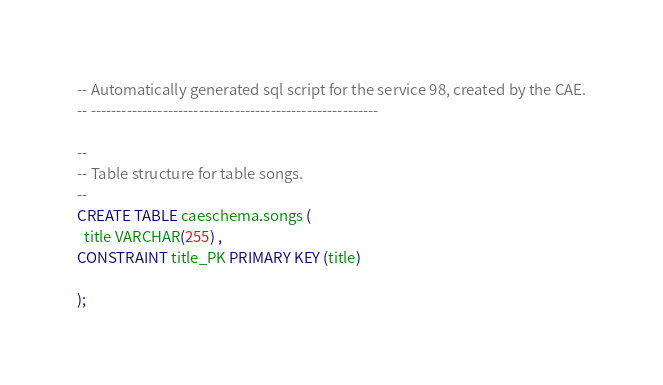Convert code to text. <code><loc_0><loc_0><loc_500><loc_500><_SQL_>-- Automatically generated sql script for the service 98, created by the CAE.
-- --------------------------------------------------------

--
-- Table structure for table songs.
--
CREATE TABLE caeschema.songs (
  title VARCHAR(255) ,
CONSTRAINT title_PK PRIMARY KEY (title)
 
);



</code> 